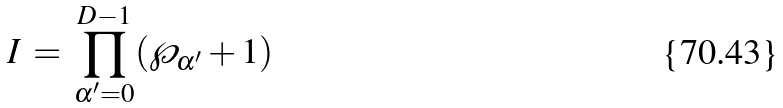<formula> <loc_0><loc_0><loc_500><loc_500>I \, = \, \prod _ { \alpha ^ { \prime } = 0 } ^ { D - 1 } ( \wp _ { \alpha ^ { \prime } } + 1 )</formula> 